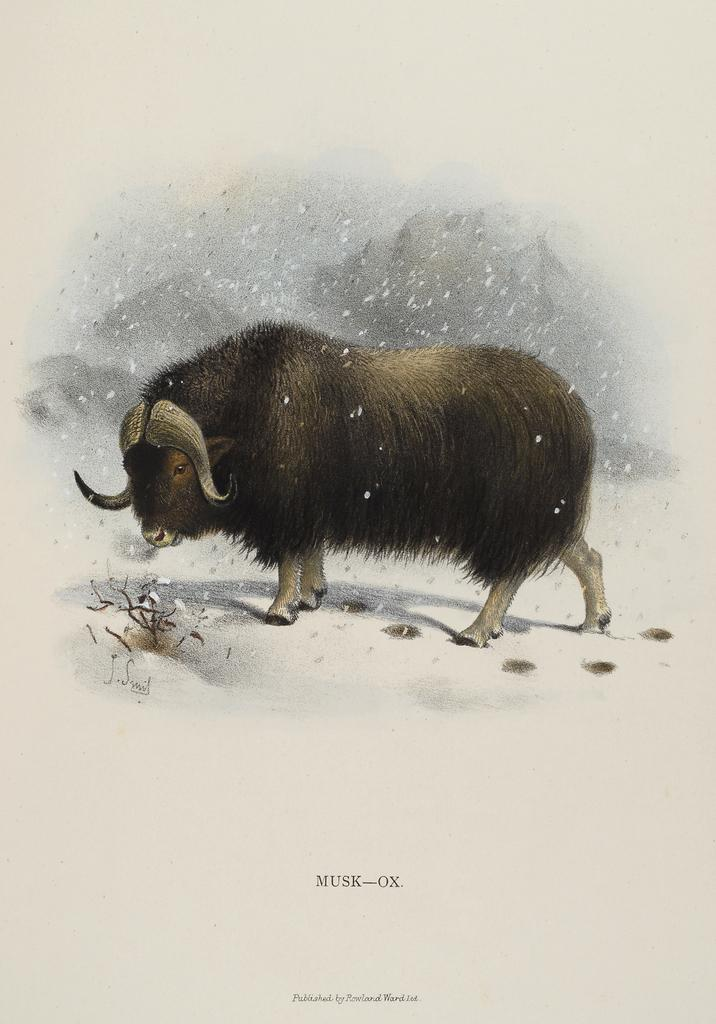What animal is the main subject of the image? There is a black color bull in the image. What is the background of the image? There is snow visible in the image. How many spiders are crawling on the bull in the image? There are no spiders present in the image; it features a black color bull in the snow. What territory does the bull claim in the image? The image does not depict the bull claiming any territory; it simply shows the bull in the snow. 